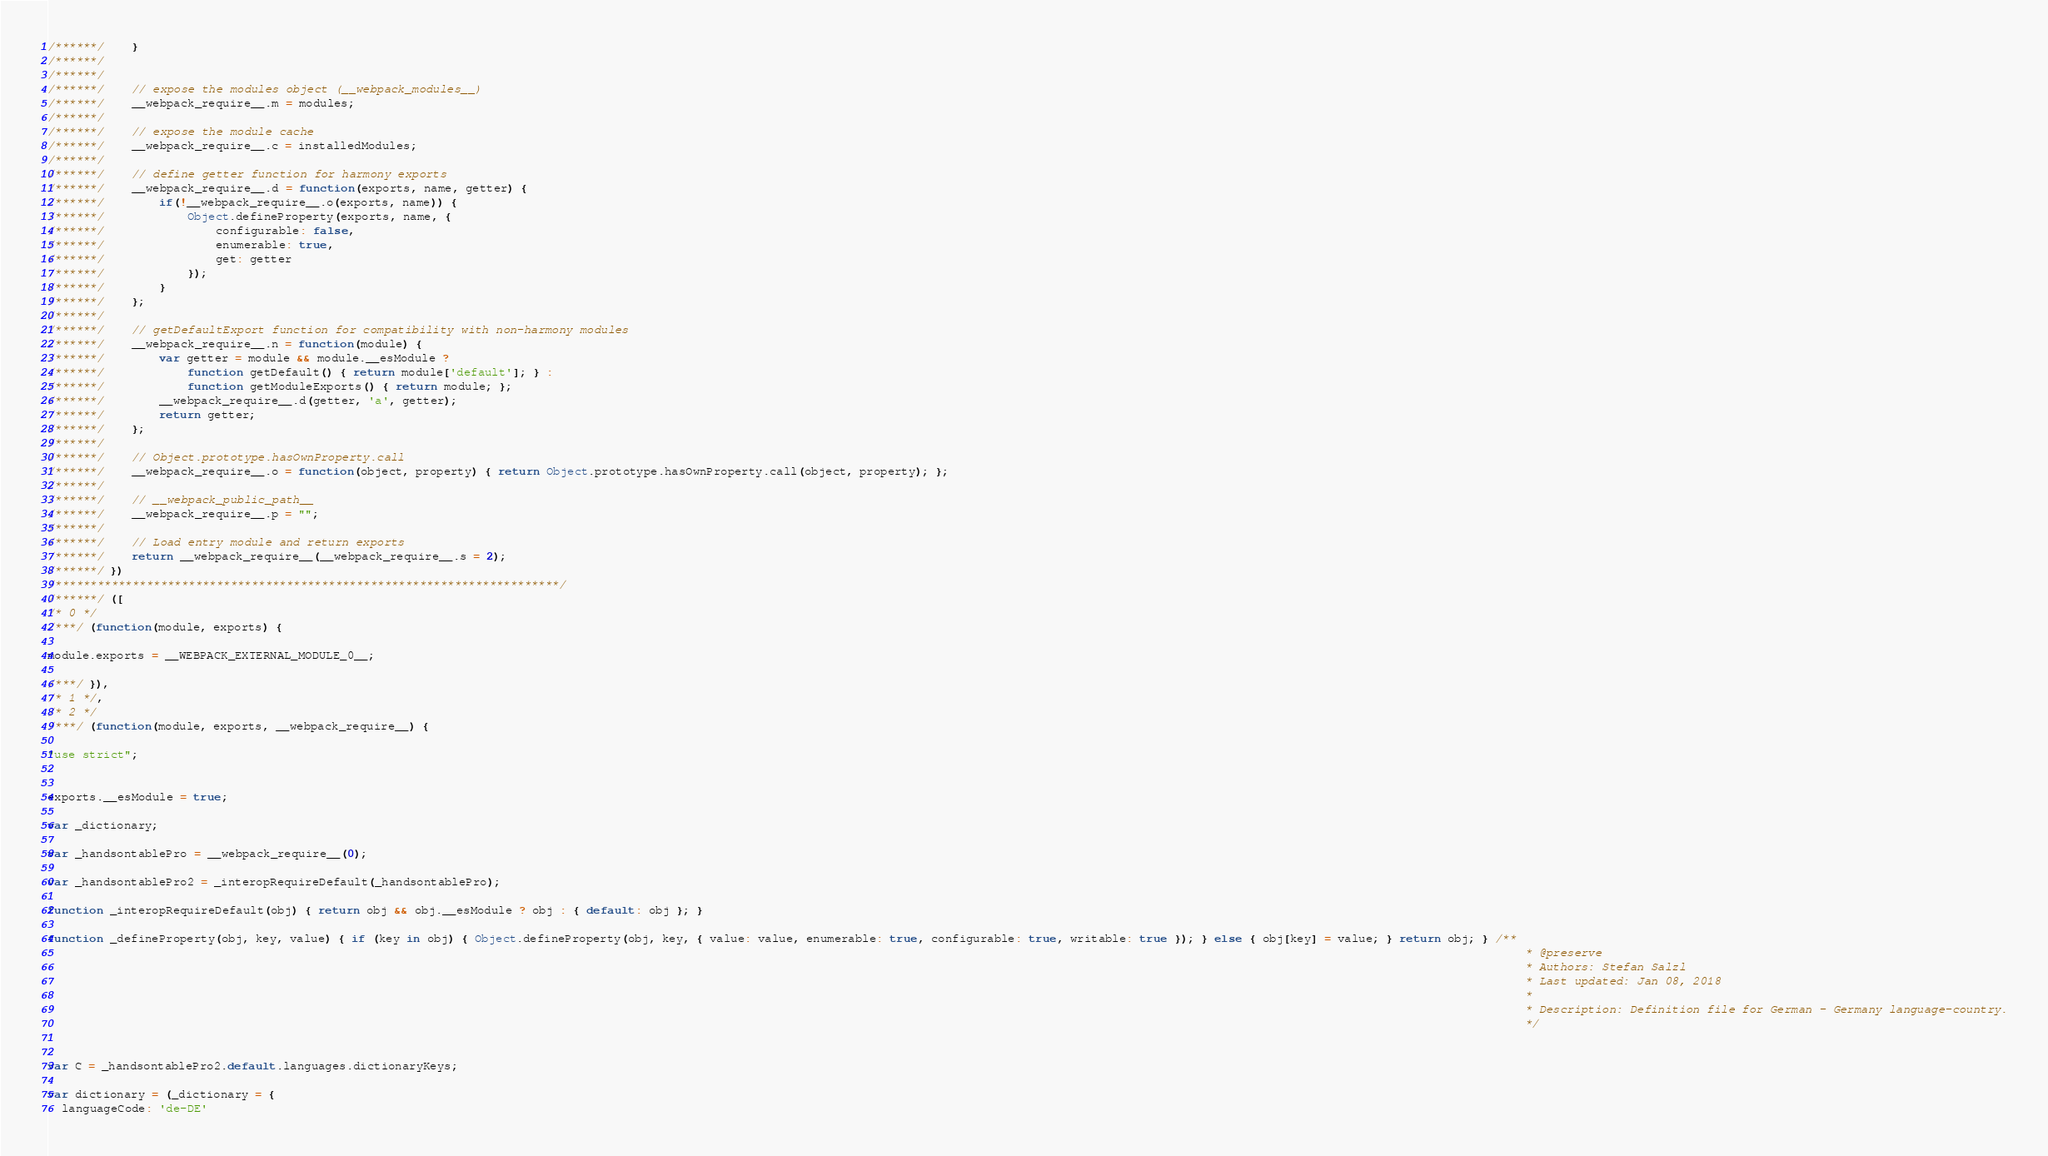<code> <loc_0><loc_0><loc_500><loc_500><_JavaScript_>/******/ 	}
/******/
/******/
/******/ 	// expose the modules object (__webpack_modules__)
/******/ 	__webpack_require__.m = modules;
/******/
/******/ 	// expose the module cache
/******/ 	__webpack_require__.c = installedModules;
/******/
/******/ 	// define getter function for harmony exports
/******/ 	__webpack_require__.d = function(exports, name, getter) {
/******/ 		if(!__webpack_require__.o(exports, name)) {
/******/ 			Object.defineProperty(exports, name, {
/******/ 				configurable: false,
/******/ 				enumerable: true,
/******/ 				get: getter
/******/ 			});
/******/ 		}
/******/ 	};
/******/
/******/ 	// getDefaultExport function for compatibility with non-harmony modules
/******/ 	__webpack_require__.n = function(module) {
/******/ 		var getter = module && module.__esModule ?
/******/ 			function getDefault() { return module['default']; } :
/******/ 			function getModuleExports() { return module; };
/******/ 		__webpack_require__.d(getter, 'a', getter);
/******/ 		return getter;
/******/ 	};
/******/
/******/ 	// Object.prototype.hasOwnProperty.call
/******/ 	__webpack_require__.o = function(object, property) { return Object.prototype.hasOwnProperty.call(object, property); };
/******/
/******/ 	// __webpack_public_path__
/******/ 	__webpack_require__.p = "";
/******/
/******/ 	// Load entry module and return exports
/******/ 	return __webpack_require__(__webpack_require__.s = 2);
/******/ })
/************************************************************************/
/******/ ([
/* 0 */
/***/ (function(module, exports) {

module.exports = __WEBPACK_EXTERNAL_MODULE_0__;

/***/ }),
/* 1 */,
/* 2 */
/***/ (function(module, exports, __webpack_require__) {

"use strict";


exports.__esModule = true;

var _dictionary;

var _handsontablePro = __webpack_require__(0);

var _handsontablePro2 = _interopRequireDefault(_handsontablePro);

function _interopRequireDefault(obj) { return obj && obj.__esModule ? obj : { default: obj }; }

function _defineProperty(obj, key, value) { if (key in obj) { Object.defineProperty(obj, key, { value: value, enumerable: true, configurable: true, writable: true }); } else { obj[key] = value; } return obj; } /**
                                                                                                                                                                                                                   * @preserve
                                                                                                                                                                                                                   * Authors: Stefan Salzl
                                                                                                                                                                                                                   * Last updated: Jan 08, 2018
                                                                                                                                                                                                                   *
                                                                                                                                                                                                                   * Description: Definition file for German - Germany language-country.
                                                                                                                                                                                                                   */


var C = _handsontablePro2.default.languages.dictionaryKeys;

var dictionary = (_dictionary = {
  languageCode: 'de-DE'</code> 